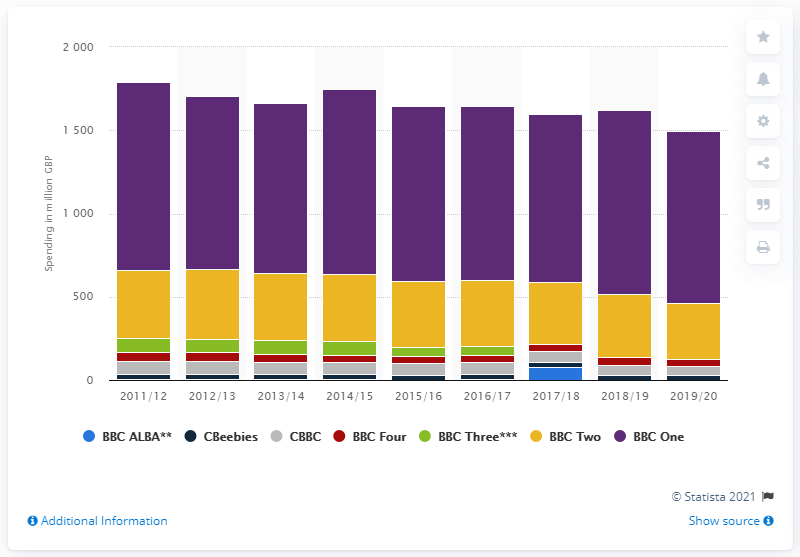Highlight a few significant elements in this photo. In 2011/12, the BBC displayed information on its content spending by channel in the UK. In the year 2019/2020, BBC One spent over one billion pounds. 